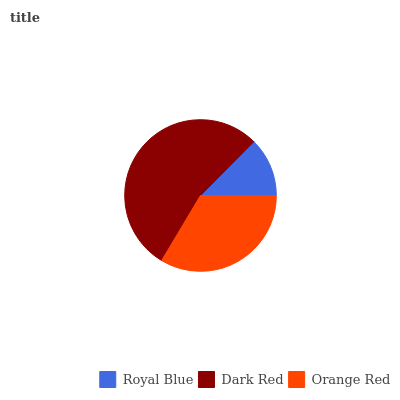Is Royal Blue the minimum?
Answer yes or no. Yes. Is Dark Red the maximum?
Answer yes or no. Yes. Is Orange Red the minimum?
Answer yes or no. No. Is Orange Red the maximum?
Answer yes or no. No. Is Dark Red greater than Orange Red?
Answer yes or no. Yes. Is Orange Red less than Dark Red?
Answer yes or no. Yes. Is Orange Red greater than Dark Red?
Answer yes or no. No. Is Dark Red less than Orange Red?
Answer yes or no. No. Is Orange Red the high median?
Answer yes or no. Yes. Is Orange Red the low median?
Answer yes or no. Yes. Is Dark Red the high median?
Answer yes or no. No. Is Dark Red the low median?
Answer yes or no. No. 